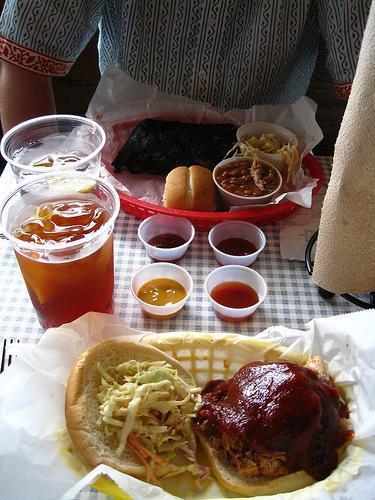How many trays are in the picture?
Give a very brief answer. 2. 